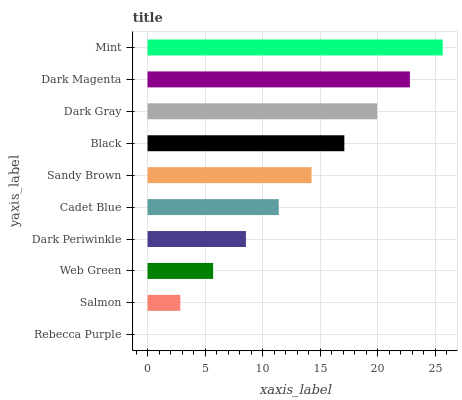Is Rebecca Purple the minimum?
Answer yes or no. Yes. Is Mint the maximum?
Answer yes or no. Yes. Is Salmon the minimum?
Answer yes or no. No. Is Salmon the maximum?
Answer yes or no. No. Is Salmon greater than Rebecca Purple?
Answer yes or no. Yes. Is Rebecca Purple less than Salmon?
Answer yes or no. Yes. Is Rebecca Purple greater than Salmon?
Answer yes or no. No. Is Salmon less than Rebecca Purple?
Answer yes or no. No. Is Sandy Brown the high median?
Answer yes or no. Yes. Is Cadet Blue the low median?
Answer yes or no. Yes. Is Mint the high median?
Answer yes or no. No. Is Black the low median?
Answer yes or no. No. 